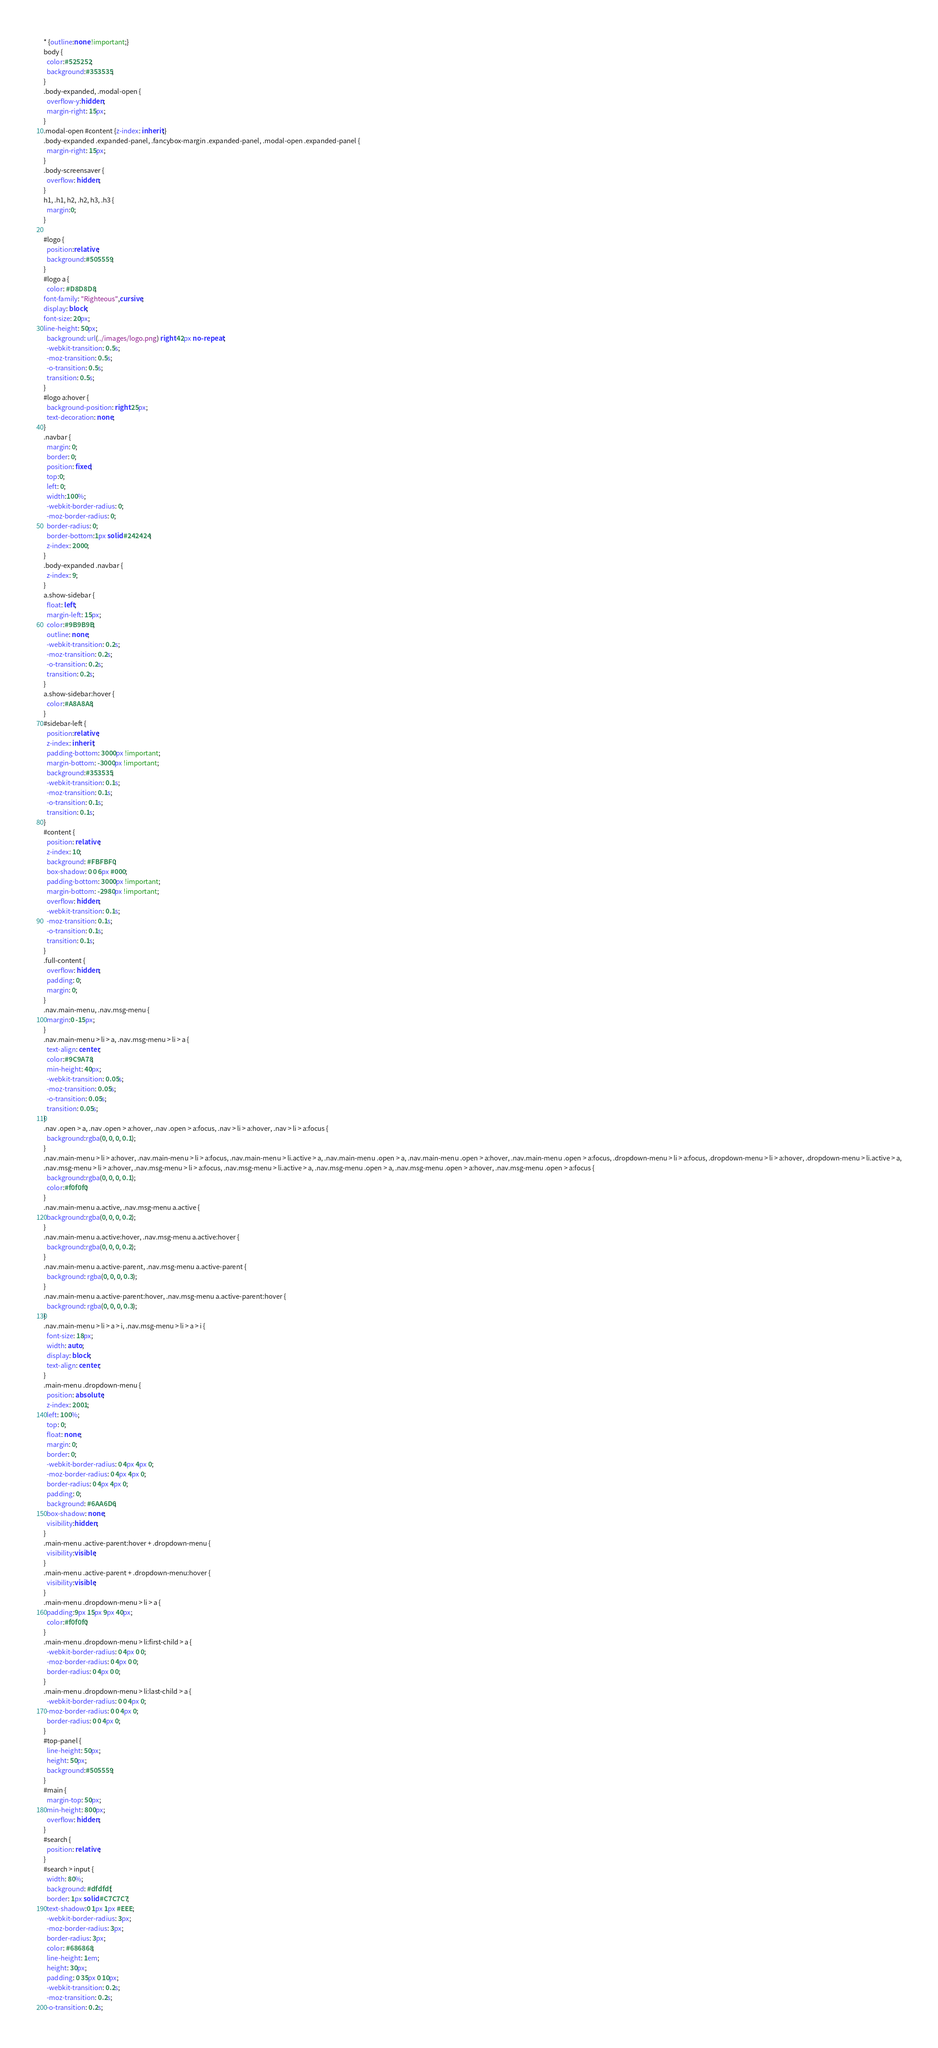Convert code to text. <code><loc_0><loc_0><loc_500><loc_500><_CSS_>* {outline:none !important;}
body {
  color:#525252;
  background:#353535;
}
.body-expanded, .modal-open {
  overflow-y:hidden;
  margin-right: 15px;
}
.modal-open #content {z-index: inherit;}
.body-expanded .expanded-panel, .fancybox-margin .expanded-panel, .modal-open .expanded-panel {
  margin-right: 15px;
}
.body-screensaver {
  overflow: hidden;
}
h1, .h1, h2, .h2, h3, .h3 {
  margin:0;
}

#logo {
  position:relative;
  background:#505559;
}
#logo a {
  color: #D8D8D8;
font-family: "Righteous",cursive;
display: block;
font-size: 20px;
line-height: 50px;
  background: url(../images/logo.png) right 42px no-repeat;
  -webkit-transition: 0.5s;
  -moz-transition: 0.5s;
  -o-transition: 0.5s;
  transition: 0.5s;
}
#logo a:hover {
  background-position: right 25px;
  text-decoration: none;
}
.navbar {
  margin: 0;
  border: 0;
  position: fixed;
  top:0;
  left: 0;
  width:100%;
  -webkit-border-radius: 0;
  -moz-border-radius: 0;
  border-radius: 0;
  border-bottom:1px solid #242424;
  z-index: 2000;
}
.body-expanded .navbar {
  z-index: 9;
}
a.show-sidebar {
  float: left;
  margin-left: 15px;
  color:#9B9B9B;
  outline: none;
  -webkit-transition: 0.2s;
  -moz-transition: 0.2s;
  -o-transition: 0.2s;
  transition: 0.2s;
}
a.show-sidebar:hover {
  color:#A8A8A8;
}
#sidebar-left {
  position:relative;
  z-index: inherit;
  padding-bottom: 3000px !important;
  margin-bottom: -3000px !important;
  background:#353535;
  -webkit-transition: 0.1s;
  -moz-transition: 0.1s;
  -o-transition: 0.1s;
  transition: 0.1s;
}
#content {
  position: relative;
  z-index: 10;
  background: #FBFBF0;
  box-shadow: 0 0 6px #000;
  padding-bottom: 3000px !important;
  margin-bottom: -2980px !important;
  overflow: hidden;
  -webkit-transition: 0.1s;
  -moz-transition: 0.1s;
  -o-transition: 0.1s;
  transition: 0.1s;
}
.full-content {
  overflow: hidden;
  padding: 0;
  margin: 0;
}
.nav.main-menu, .nav.msg-menu {
  margin:0 -15px;
}
.nav.main-menu > li > a, .nav.msg-menu > li > a {
  text-align: center;
  color:#9C9A78;
  min-height: 40px;
  -webkit-transition: 0.05s;
  -moz-transition: 0.05s;
  -o-transition: 0.05s;
  transition: 0.05s;
}
.nav .open > a, .nav .open > a:hover, .nav .open > a:focus, .nav > li > a:hover, .nav > li > a:focus {
  background:rgba(0, 0, 0, 0.1);
}
.nav.main-menu > li > a:hover, .nav.main-menu > li > a:focus, .nav.main-menu > li.active > a, .nav.main-menu .open > a, .nav.main-menu .open > a:hover, .nav.main-menu .open > a:focus, .dropdown-menu > li > a:focus, .dropdown-menu > li > a:hover, .dropdown-menu > li.active > a,
.nav.msg-menu > li > a:hover, .nav.msg-menu > li > a:focus, .nav.msg-menu > li.active > a, .nav.msg-menu .open > a, .nav.msg-menu .open > a:hover, .nav.msg-menu .open > a:focus {
  background:rgba(0, 0, 0, 0.1);
  color:#f0f0f0;
}
.nav.main-menu a.active, .nav.msg-menu a.active {
  background:rgba(0, 0, 0, 0.2);
}
.nav.main-menu a.active:hover, .nav.msg-menu a.active:hover {
  background:rgba(0, 0, 0, 0.2);
}
.nav.main-menu a.active-parent, .nav.msg-menu a.active-parent {
  background: rgba(0, 0, 0, 0.3);
}
.nav.main-menu a.active-parent:hover, .nav.msg-menu a.active-parent:hover {
  background: rgba(0, 0, 0, 0.3);
}
.nav.main-menu > li > a > i, .nav.msg-menu > li > a > i {
  font-size: 18px;
  width: auto;
  display: block;
  text-align: center;
}
.main-menu .dropdown-menu {
  position: absolute;
  z-index: 2001;
  left: 100%;
  top: 0;
  float: none;
  margin: 0;
  border: 0;
  -webkit-border-radius: 0 4px 4px 0;
  -moz-border-radius: 0 4px 4px 0;
  border-radius: 0 4px 4px 0;
  padding: 0;
  background: #6AA6D6;
  box-shadow: none;
  visibility:hidden;
}
.main-menu .active-parent:hover + .dropdown-menu {
  visibility:visible;
}
.main-menu .active-parent + .dropdown-menu:hover {
  visibility:visible;
}
.main-menu .dropdown-menu > li > a {
  padding:9px 15px 9px 40px;
  color:#f0f0f0;
}
.main-menu .dropdown-menu > li:first-child > a {
  -webkit-border-radius: 0 4px 0 0;
  -moz-border-radius: 0 4px 0 0;
  border-radius: 0 4px 0 0;
}
.main-menu .dropdown-menu > li:last-child > a {
  -webkit-border-radius: 0 0 4px 0;
  -moz-border-radius: 0 0 4px 0;
  border-radius: 0 0 4px 0;
}
#top-panel {
  line-height: 50px;
  height: 50px;
  background:#505559;
}
#main {
  margin-top: 50px;
  min-height: 800px;
  overflow: hidden;
}
#search {
  position: relative;
}
#search > input {
  width: 80%;
  background: #dfdfdf;
  border: 1px solid #C7C7C7;
  text-shadow:0 1px 1px #EEE;
  -webkit-border-radius: 3px;
  -moz-border-radius: 3px;
  border-radius: 3px;
  color: #686868;
  line-height: 1em;
  height: 30px;
  padding: 0 35px 0 10px;
  -webkit-transition: 0.2s;
  -moz-transition: 0.2s;
  -o-transition: 0.2s;</code> 